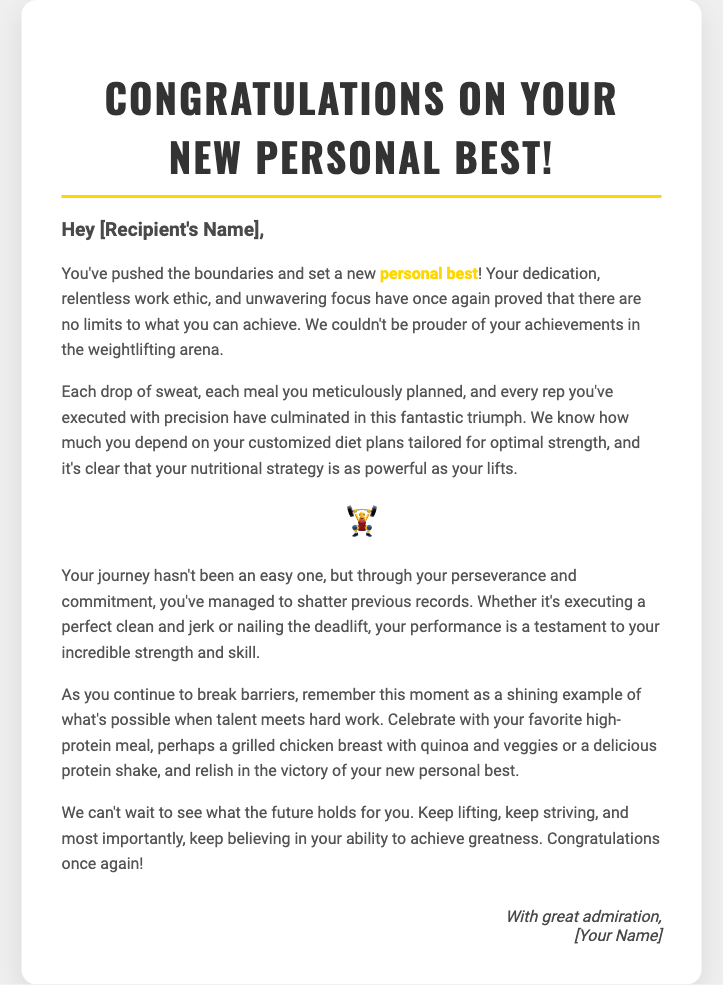What is the title of the card? The title of the card is displayed prominently at the top and reads "Congratulations on Your New Personal Best!"
Answer: Congratulations on Your New Personal Best! Who is the recipient addressed in the greeting? The greeting includes a placeholder for the recipient's name, which is indicated as "[Recipient's Name]."
Answer: [Recipient's Name] What emoji is used in the card? The card features an emoji that represents weightlifting, which adds a celebratory tone to the message.
Answer: 🏋️‍♂️ What type of meal is suggested for celebration? The text suggests a specific meal for celebration, highlighting the focus on nutrition as part of the recipient's training.
Answer: grilled chicken breast with quinoa and veggies What concept is emphasized as important in achieving personal bests? The card emphasizes the importance of a specific strategy that relates to the recipient's nutrition and training routine.
Answer: customized diet plans How does the card describe the recipient's journey? The card notes that the recipient's journey has not been easy and praises their resilience and commitment to their goals.
Answer: perseverance and commitment What do the authors express about the future? The authors express anticipation and excitement regarding the recipient's future achievements in weightlifting.
Answer: can't wait to see what the future holds What does the closure of the card convey? The closure of the card expresses admiration and is personalized with a placeholder for the sender's name.
Answer: With great admiration 